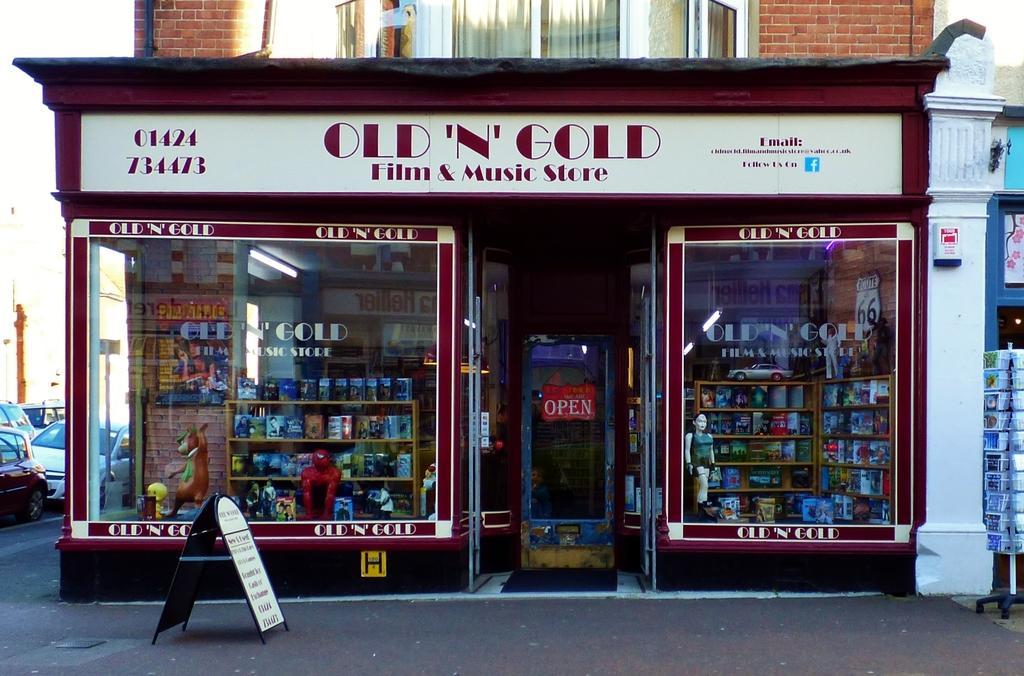In one or two sentences, can you explain what this image depicts? In the picture we can see a shop with a glass walls from it, we can see some toys and music albums and beside the shop we can see a board stand on the path and on the road we can see some vehicles, and the name of the shop is old and gold music store. 